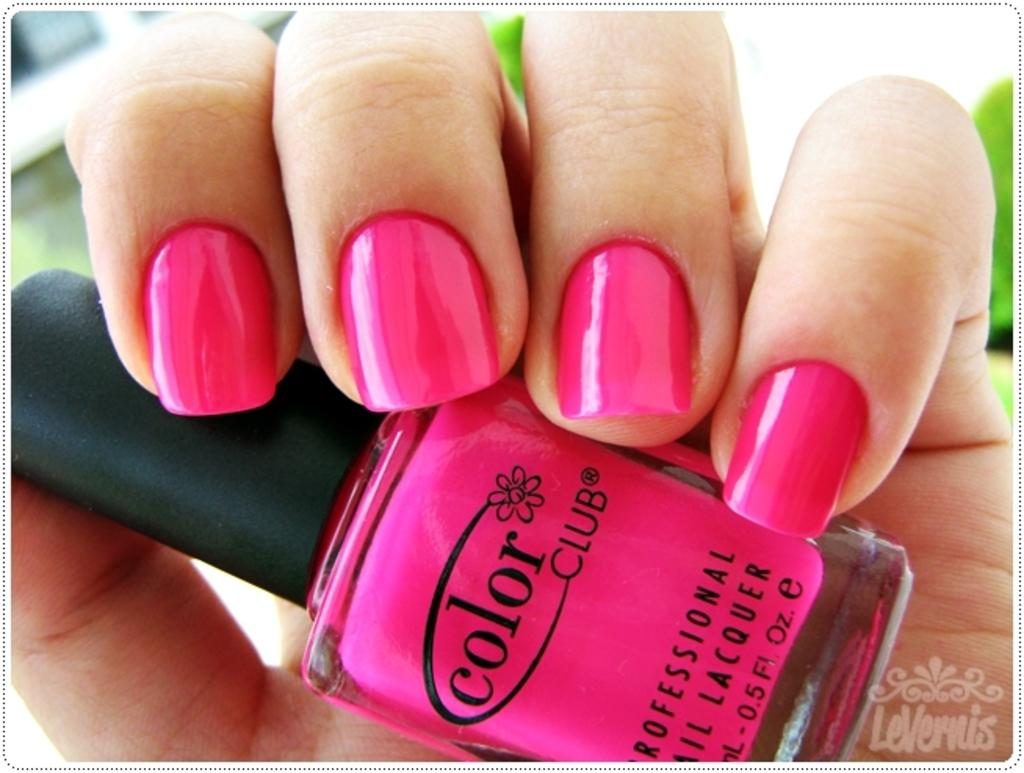What object is the main focus of the image? There is a nail-polish bottle in the image. Can you describe the colors be identified on the nail-polish bottle? Yes, the nail-polish bottle is pink and black in color. Is there any indication of who is holding the nail-polish bottle? A person is holding the nail-polish bottle, but their identity is not specified. What type of bird can be seen sitting on the nail-polish bottle in the image? There is no bird present in the image; it only features a nail-polish bottle and a person holding it. What flavor of cracker is being used to paint the person's nails in the image? There is no cracker present in the image, and the person's nails are being painted with nail polish, not crackers. 